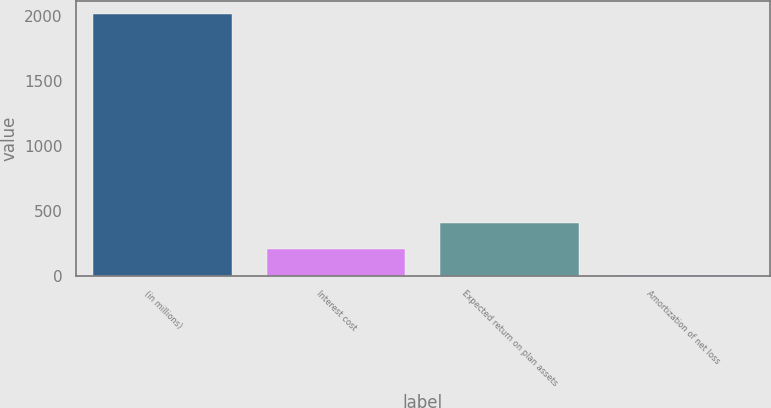Convert chart to OTSL. <chart><loc_0><loc_0><loc_500><loc_500><bar_chart><fcel>(in millions)<fcel>Interest cost<fcel>Expected return on plan assets<fcel>Amortization of net loss<nl><fcel>2013<fcel>204<fcel>405<fcel>3<nl></chart> 